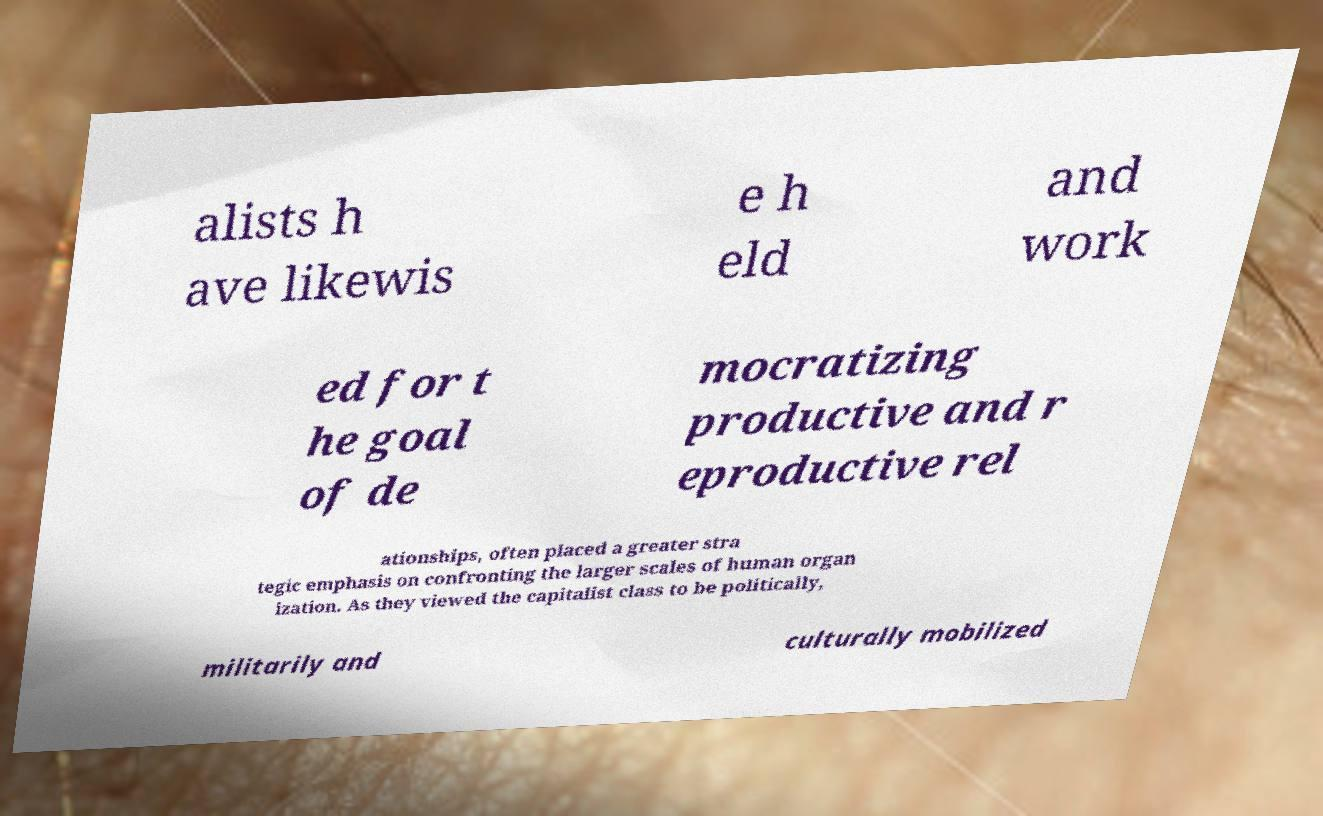Could you assist in decoding the text presented in this image and type it out clearly? alists h ave likewis e h eld and work ed for t he goal of de mocratizing productive and r eproductive rel ationships, often placed a greater stra tegic emphasis on confronting the larger scales of human organ ization. As they viewed the capitalist class to be politically, militarily and culturally mobilized 